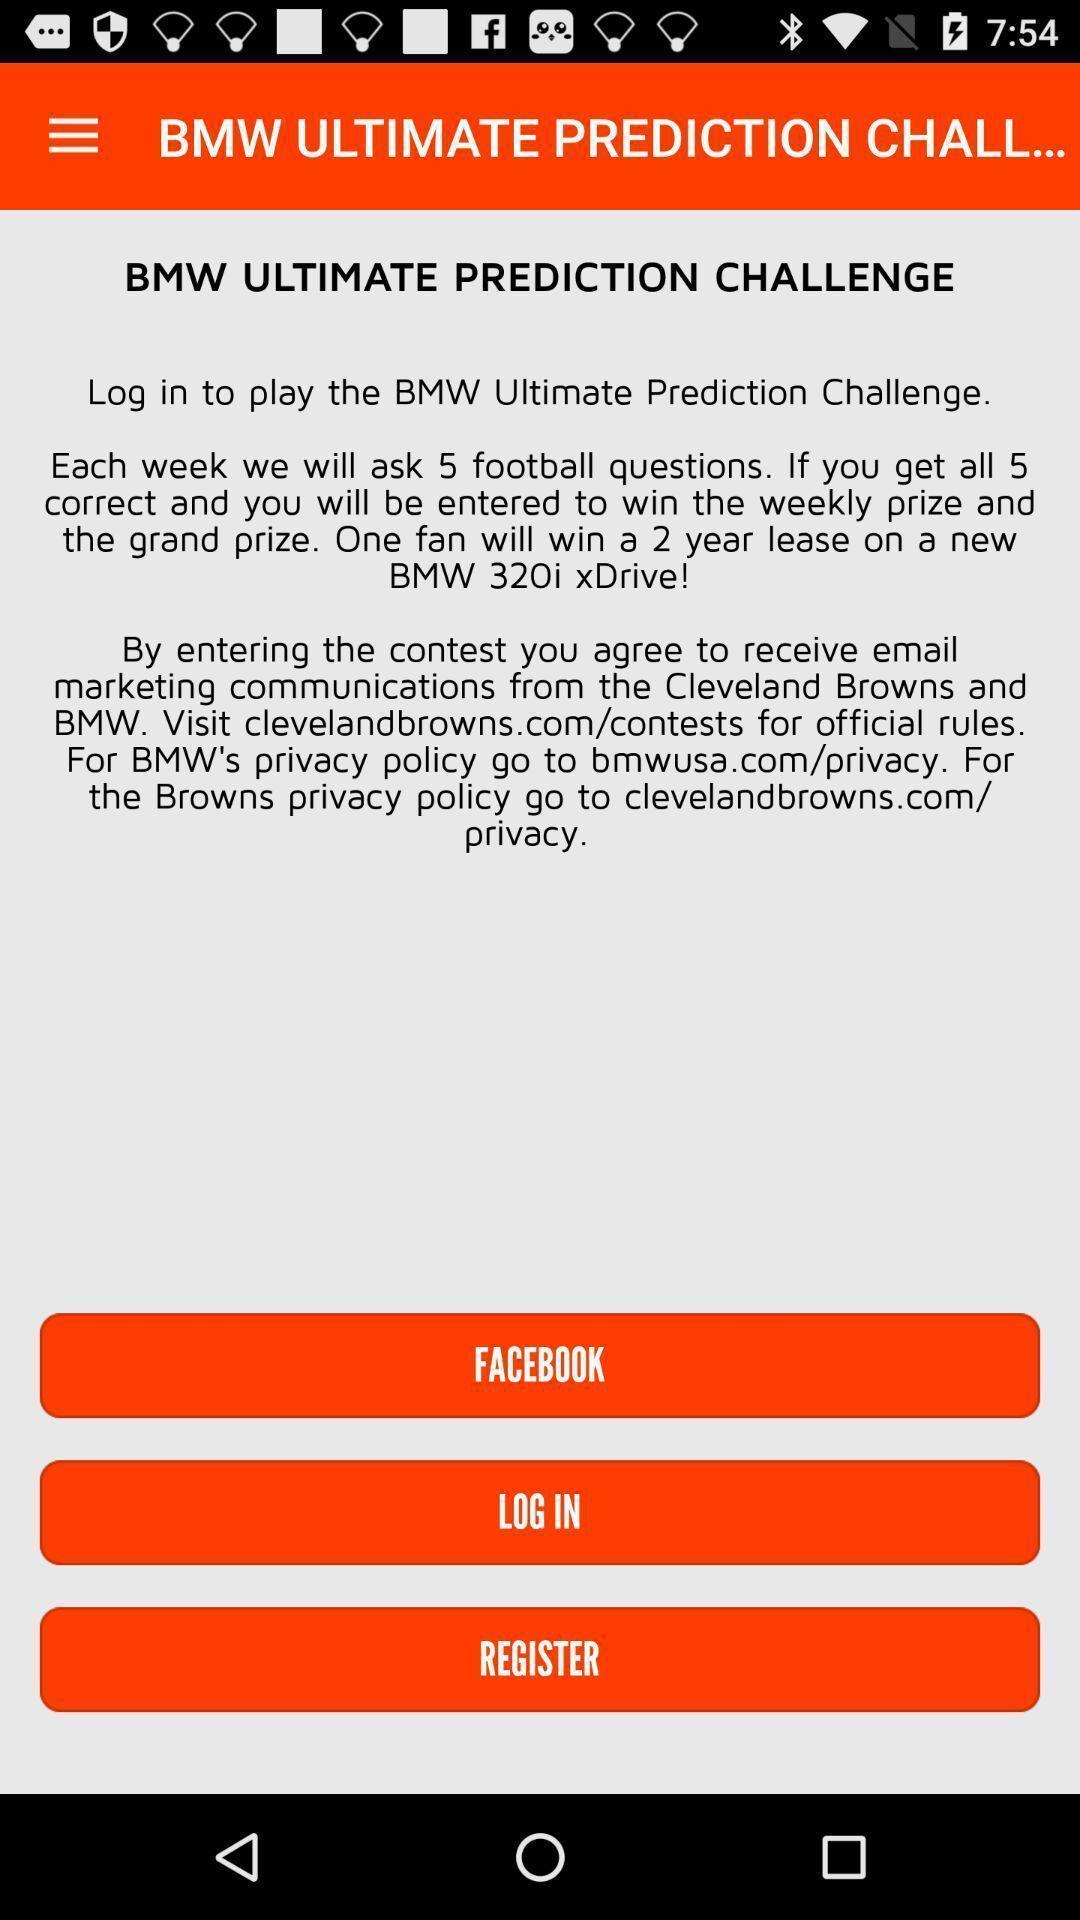Explain what's happening in this screen capture. Welcome page showing instructions in a automobile app. 